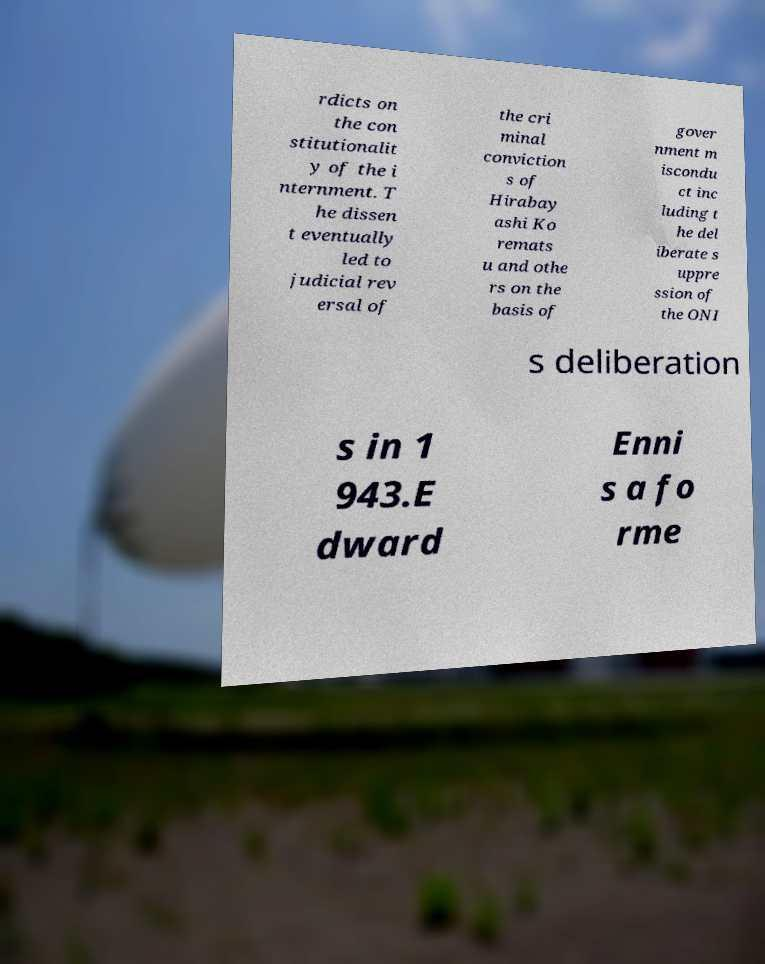Can you read and provide the text displayed in the image?This photo seems to have some interesting text. Can you extract and type it out for me? rdicts on the con stitutionalit y of the i nternment. T he dissen t eventually led to judicial rev ersal of the cri minal conviction s of Hirabay ashi Ko remats u and othe rs on the basis of gover nment m iscondu ct inc luding t he del iberate s uppre ssion of the ONI s deliberation s in 1 943.E dward Enni s a fo rme 